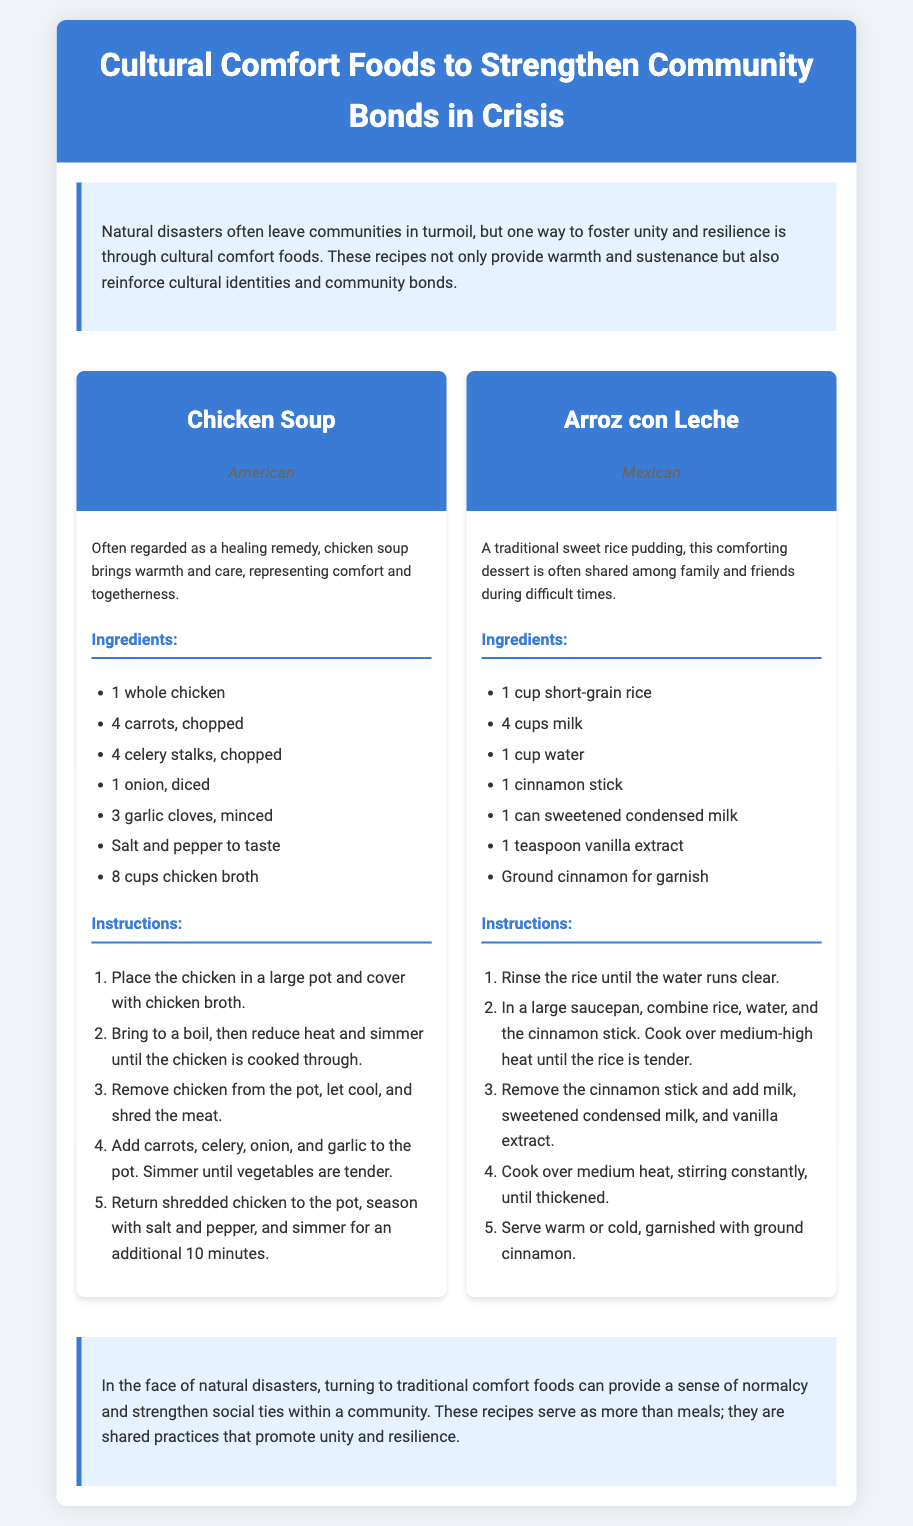what is the title of the document? The title is presented at the top of the document within the header section.
Answer: Cultural Comfort Foods to Strengthen Community Bonds in Crisis how many recipes are featured in the document? The document contains a recipe grid that lists the number of recipes provided.
Answer: 2 what is the origin of Chicken Soup? The origin of each recipe is indicated below the recipe title in the document.
Answer: American what is one key ingredient in Arroz con Leche? One ingredient is listed in the recipe card for Arroz con Leche under the ingredients section.
Answer: milk why are cultural comfort foods important during crises? The introduction explains their role in providing warmth, sustenance, and reinforcing community bonds during difficult times.
Answer: unity and resilience how many cups of chicken broth are needed for Chicken Soup? The quantity is specified in the ingredients list for the Chicken Soup recipe.
Answer: 8 cups what is one serving suggestion for Arroz con Leche? The preparation instructions indicate how to serve the dish.
Answer: warm or cold what does the recipe card format typically include? Recipe cards usually contain sections for title, origin, description, ingredients, and instructions for a dish.
Answer: title, origin, ingredients, instructions 